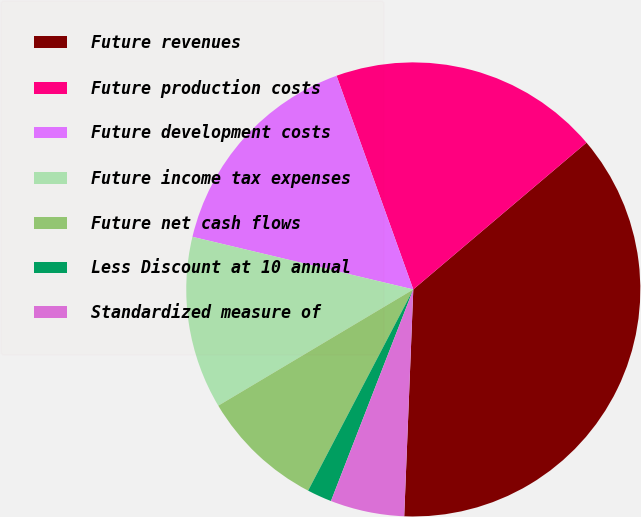Convert chart. <chart><loc_0><loc_0><loc_500><loc_500><pie_chart><fcel>Future revenues<fcel>Future production costs<fcel>Future development costs<fcel>Future income tax expenses<fcel>Future net cash flows<fcel>Less Discount at 10 annual<fcel>Standardized measure of<nl><fcel>36.83%<fcel>19.3%<fcel>15.79%<fcel>12.28%<fcel>8.78%<fcel>1.76%<fcel>5.27%<nl></chart> 